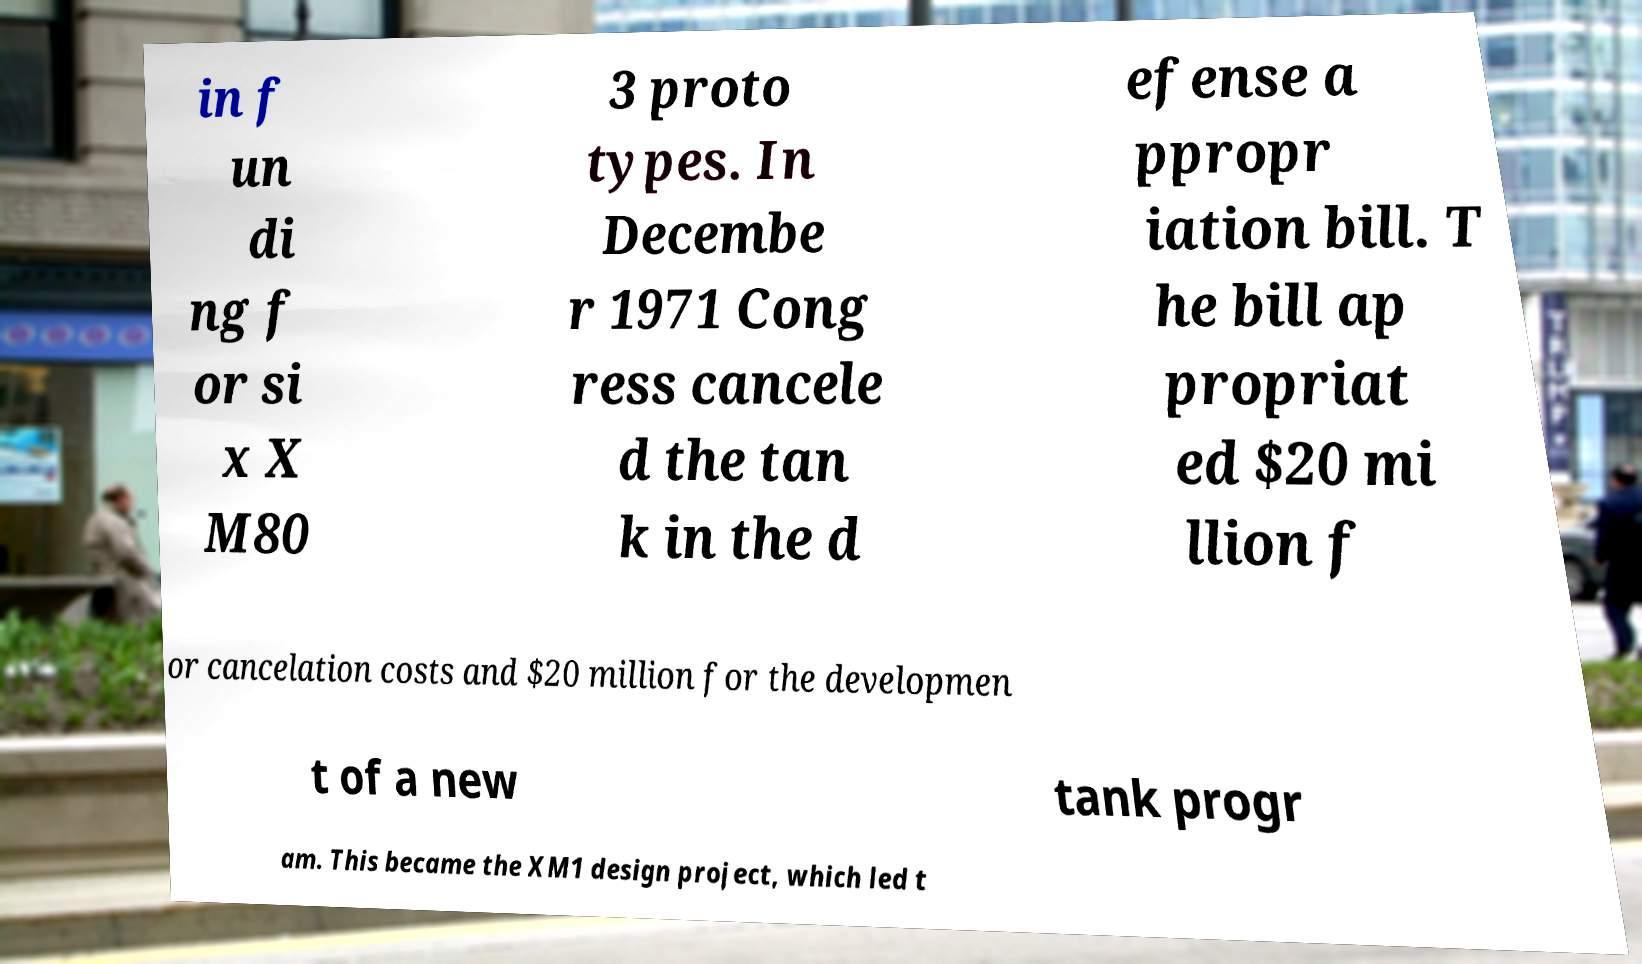I need the written content from this picture converted into text. Can you do that? in f un di ng f or si x X M80 3 proto types. In Decembe r 1971 Cong ress cancele d the tan k in the d efense a ppropr iation bill. T he bill ap propriat ed $20 mi llion f or cancelation costs and $20 million for the developmen t of a new tank progr am. This became the XM1 design project, which led t 